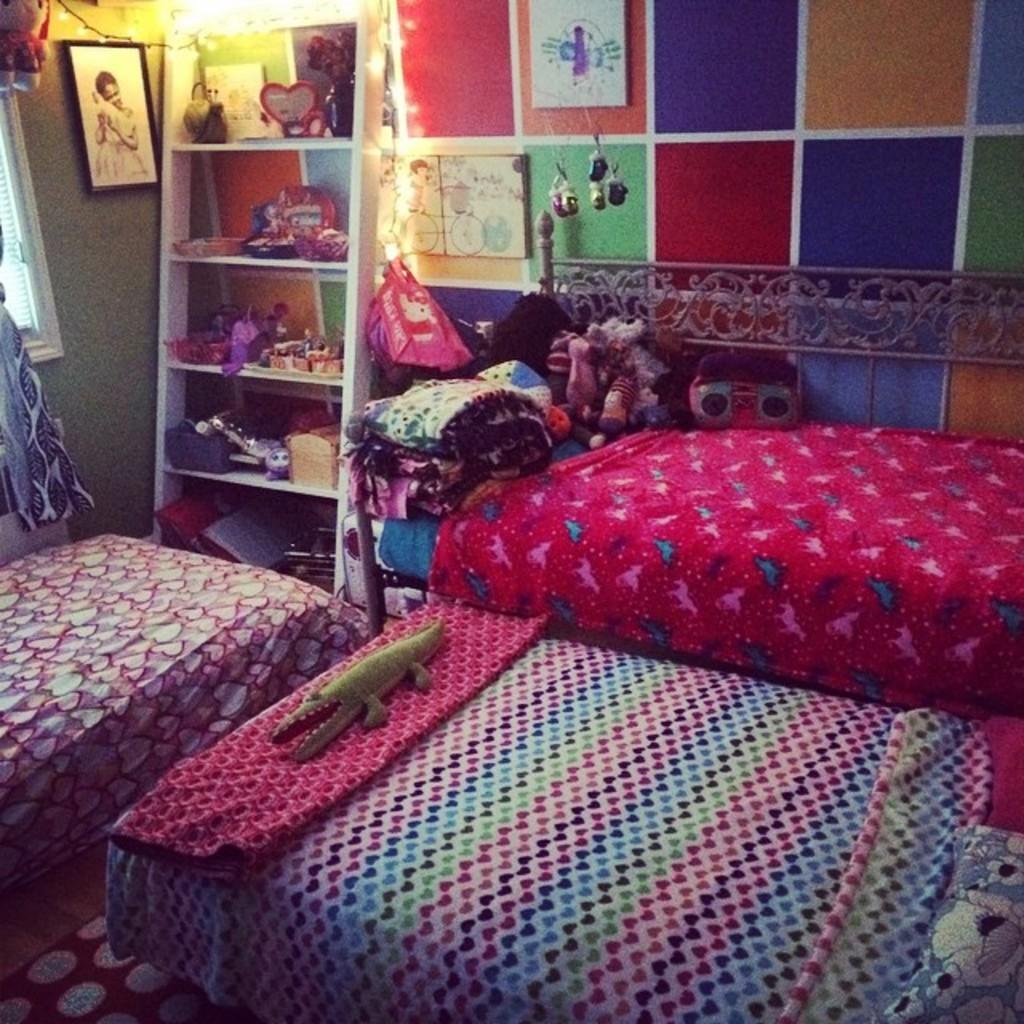Can you describe this image briefly? This picture is clicked inside the room. In this picture, we see three beds and a blanket in pink color. We see another blanket in different colors. We even see the pillows. On the left side, we see a window, curtain and a wall on which a photo frame is placed. Beside that, we see a rack in which some objects are placed. Beside that, we see a wall on which a photo frame is placed. In the left top, we see the light. 